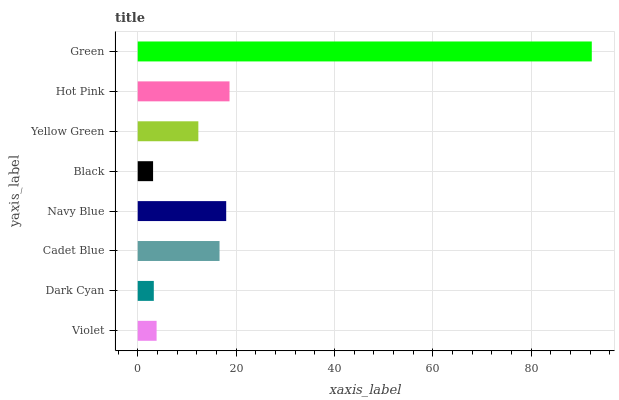Is Black the minimum?
Answer yes or no. Yes. Is Green the maximum?
Answer yes or no. Yes. Is Dark Cyan the minimum?
Answer yes or no. No. Is Dark Cyan the maximum?
Answer yes or no. No. Is Violet greater than Dark Cyan?
Answer yes or no. Yes. Is Dark Cyan less than Violet?
Answer yes or no. Yes. Is Dark Cyan greater than Violet?
Answer yes or no. No. Is Violet less than Dark Cyan?
Answer yes or no. No. Is Cadet Blue the high median?
Answer yes or no. Yes. Is Yellow Green the low median?
Answer yes or no. Yes. Is Yellow Green the high median?
Answer yes or no. No. Is Green the low median?
Answer yes or no. No. 